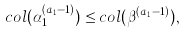Convert formula to latex. <formula><loc_0><loc_0><loc_500><loc_500>c o l ( \alpha ^ { ( a _ { 1 } - 1 ) } _ { 1 } ) \leq c o l ( \beta ^ { ( a _ { 1 } - 1 ) } ) ,</formula> 